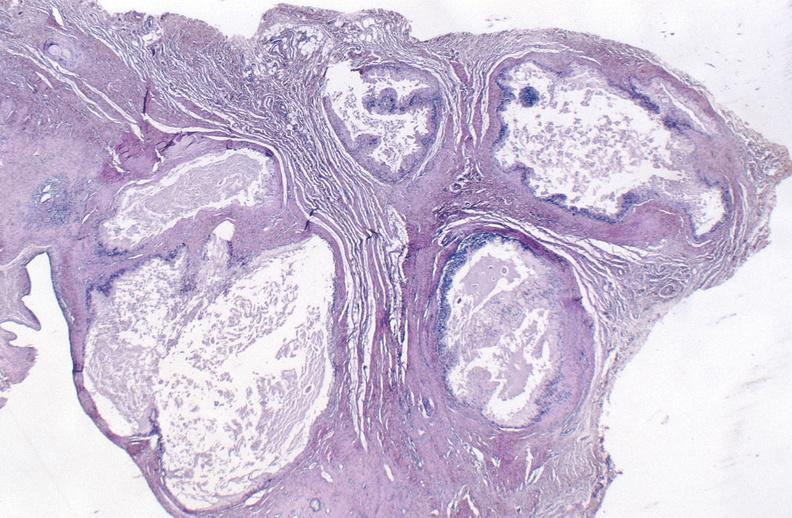does sugar coated show gout?
Answer the question using a single word or phrase. No 